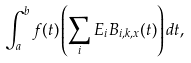Convert formula to latex. <formula><loc_0><loc_0><loc_500><loc_500>\int _ { a } ^ { b } f ( t ) \left ( \sum _ { i } E _ { i } B _ { i , k , x } ( t ) \right ) d t ,</formula> 